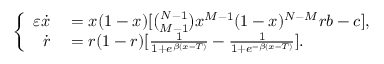<formula> <loc_0><loc_0><loc_500><loc_500>\left \{ \begin{array} { r l } { \varepsilon \dot { x } } & = x ( 1 - x ) [ \binom { N - 1 } { M - 1 } x ^ { M - 1 } ( 1 - x ) ^ { N - M } r b - c ] , } \\ { \dot { r } } & = r ( 1 - r ) [ \frac { 1 } { 1 + e ^ { \beta ( x - T ) } } - \frac { 1 } { 1 + e ^ { - \beta ( x - T ) } } ] . } \end{array}</formula> 